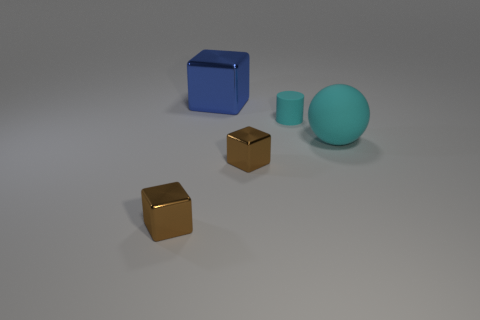Add 4 tiny cylinders. How many objects exist? 9 Subtract all big blue cubes. How many cubes are left? 2 Subtract all blue blocks. How many blocks are left? 2 Subtract 2 cubes. How many cubes are left? 1 Subtract all yellow cylinders. Subtract all brown cubes. How many cylinders are left? 1 Subtract all green spheres. How many brown cubes are left? 2 Subtract all brown cubes. Subtract all brown metallic blocks. How many objects are left? 1 Add 5 cyan balls. How many cyan balls are left? 6 Add 5 small blue matte balls. How many small blue matte balls exist? 5 Subtract 0 gray balls. How many objects are left? 5 